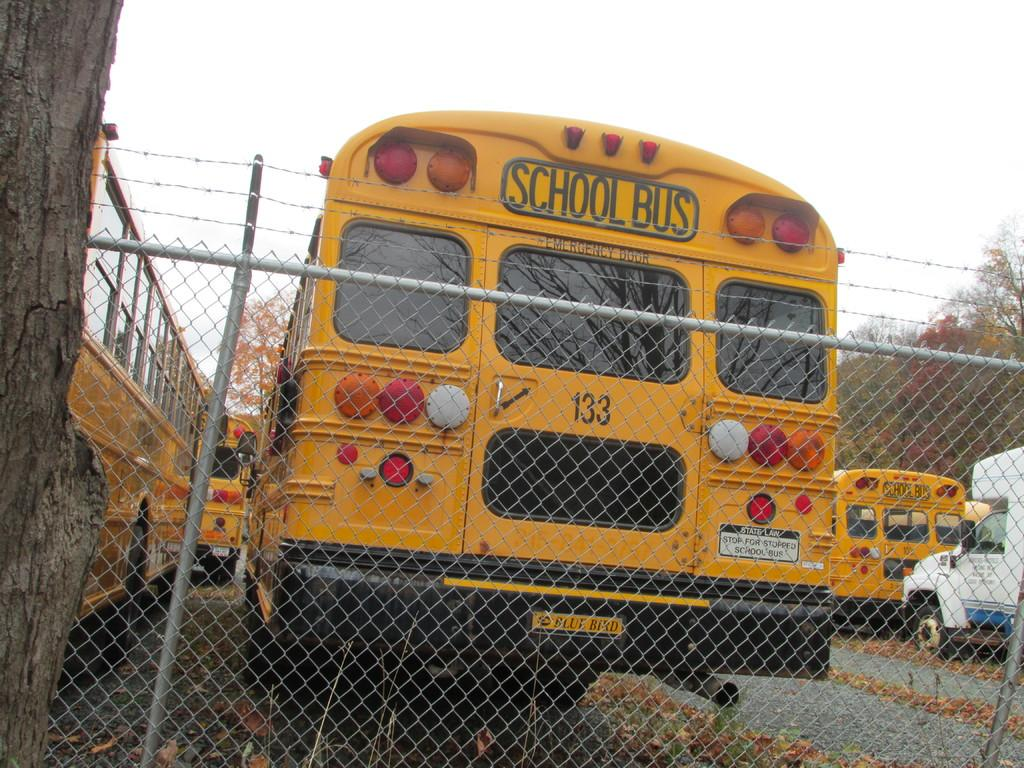<image>
Present a compact description of the photo's key features. A yellow school bus with the number 133 parked in a bus yard. 